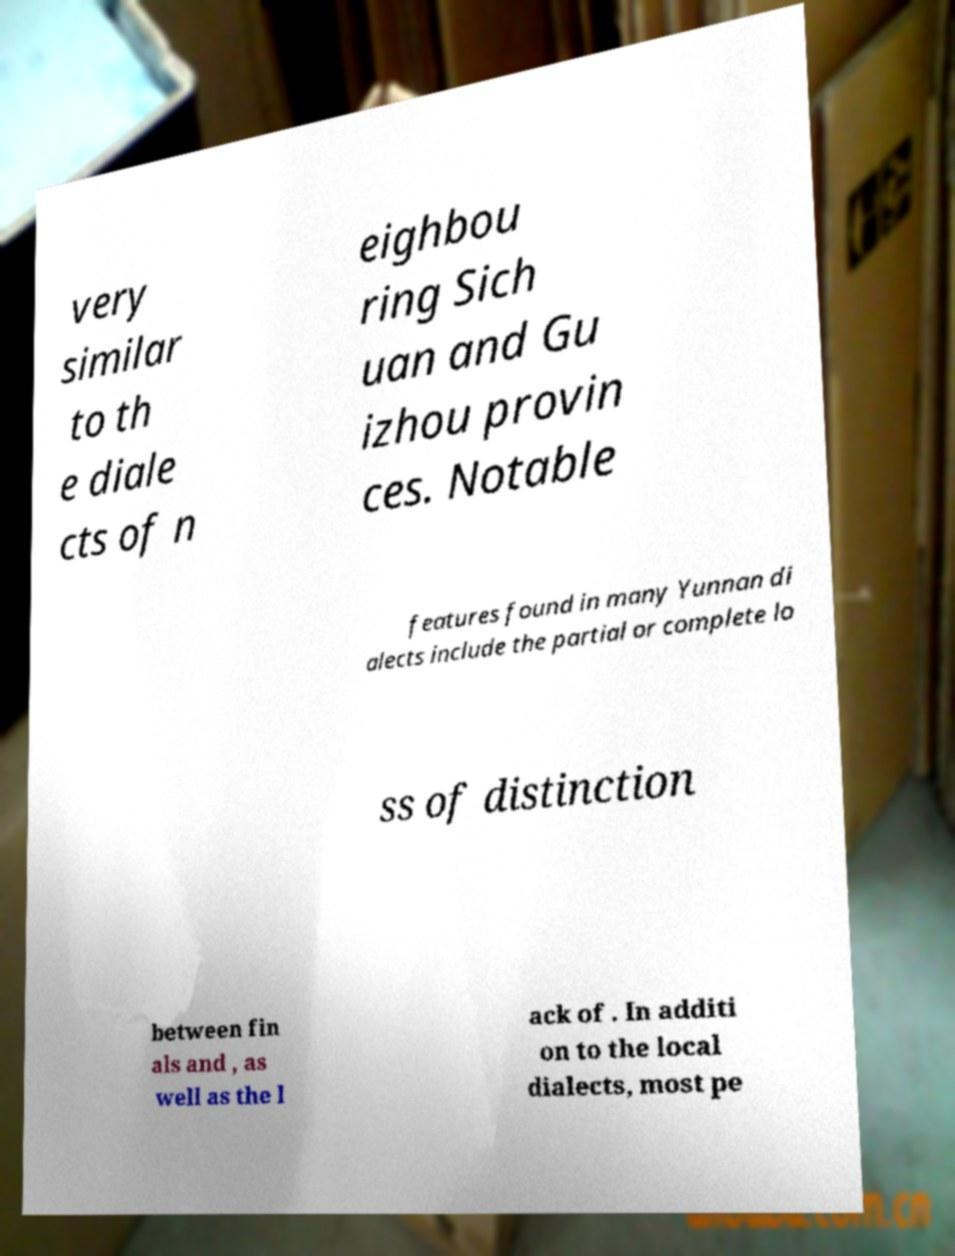Could you extract and type out the text from this image? very similar to th e diale cts of n eighbou ring Sich uan and Gu izhou provin ces. Notable features found in many Yunnan di alects include the partial or complete lo ss of distinction between fin als and , as well as the l ack of . In additi on to the local dialects, most pe 